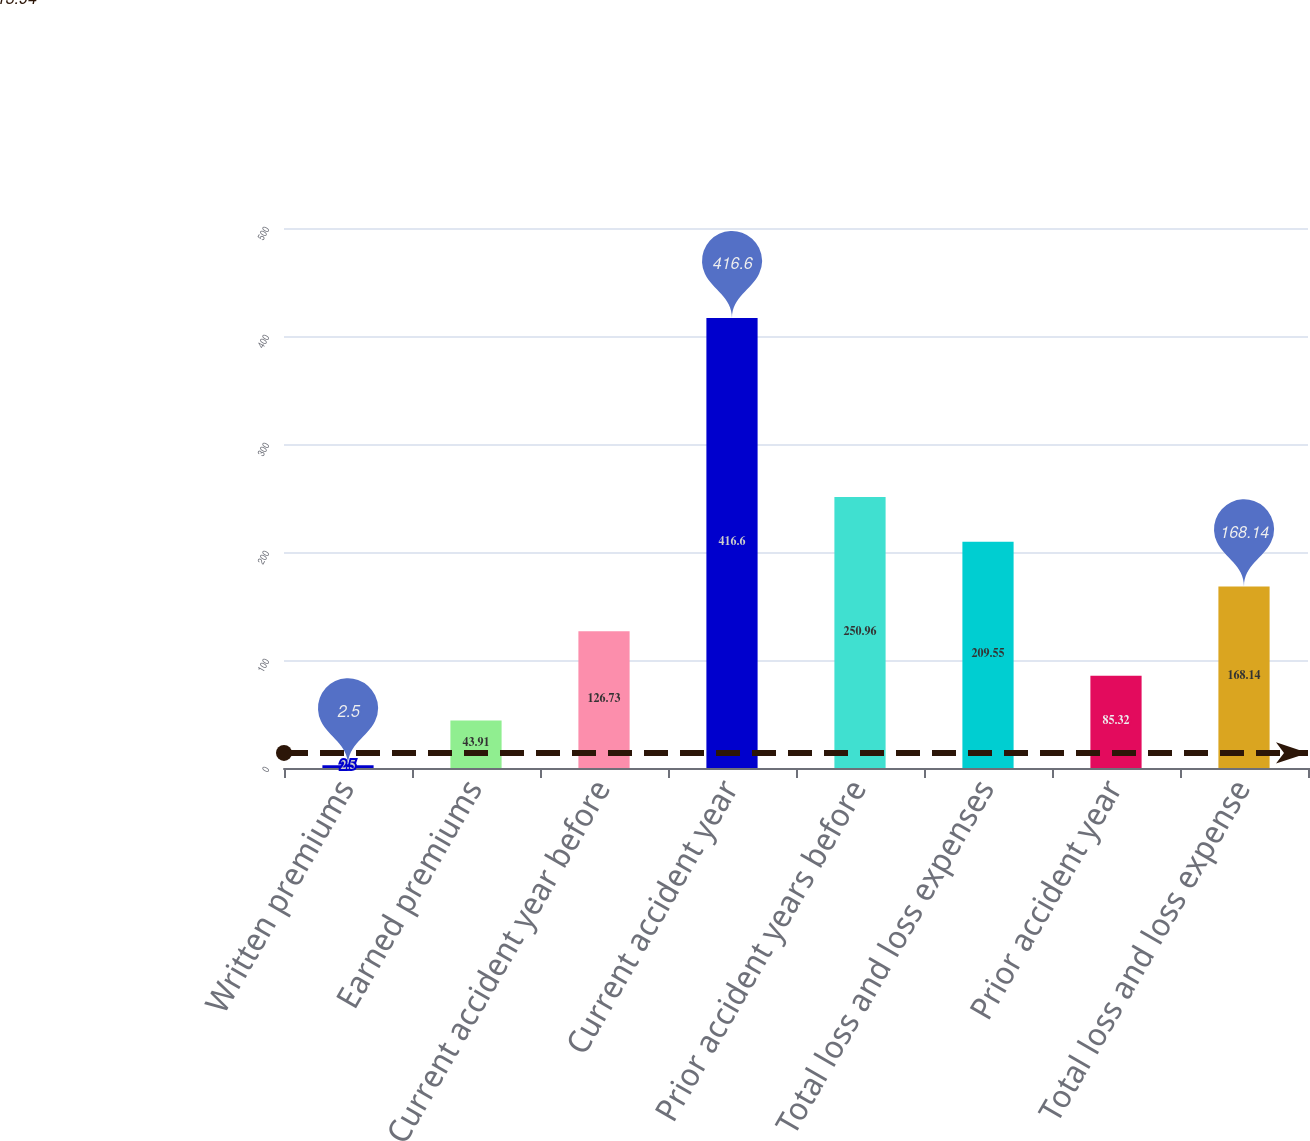Convert chart. <chart><loc_0><loc_0><loc_500><loc_500><bar_chart><fcel>Written premiums<fcel>Earned premiums<fcel>Current accident year before<fcel>Current accident year<fcel>Prior accident years before<fcel>Total loss and loss expenses<fcel>Prior accident year<fcel>Total loss and loss expense<nl><fcel>2.5<fcel>43.91<fcel>126.73<fcel>416.6<fcel>250.96<fcel>209.55<fcel>85.32<fcel>168.14<nl></chart> 